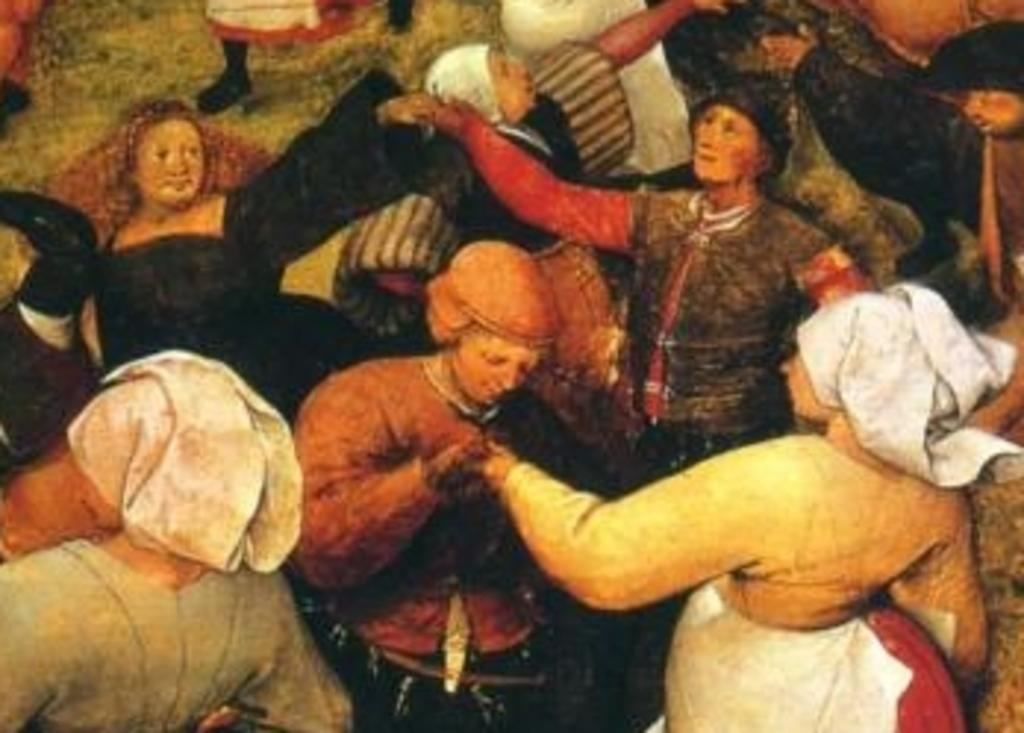What is the main subject of the image? The main subject of the image is a painting of people. What type of crib is featured in the painting? There is no crib present in the painting; it features people. What color is the shirt worn by the person in the painting? There is no person wearing a shirt in the painting, as it only depicts people in general. 